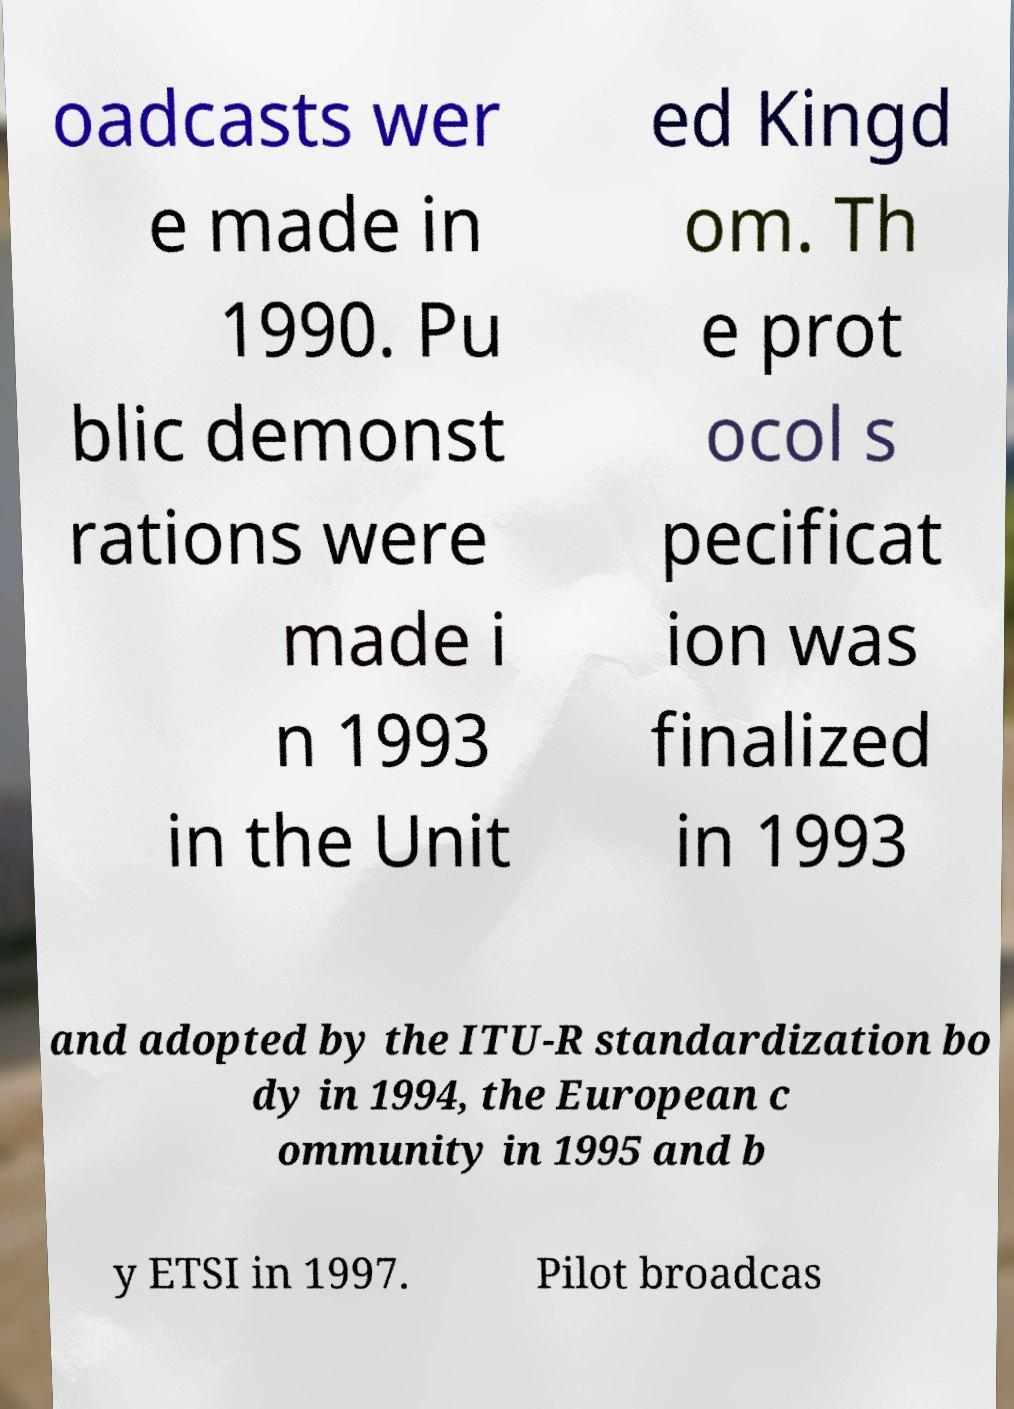There's text embedded in this image that I need extracted. Can you transcribe it verbatim? oadcasts wer e made in 1990. Pu blic demonst rations were made i n 1993 in the Unit ed Kingd om. Th e prot ocol s pecificat ion was finalized in 1993 and adopted by the ITU-R standardization bo dy in 1994, the European c ommunity in 1995 and b y ETSI in 1997. Pilot broadcas 